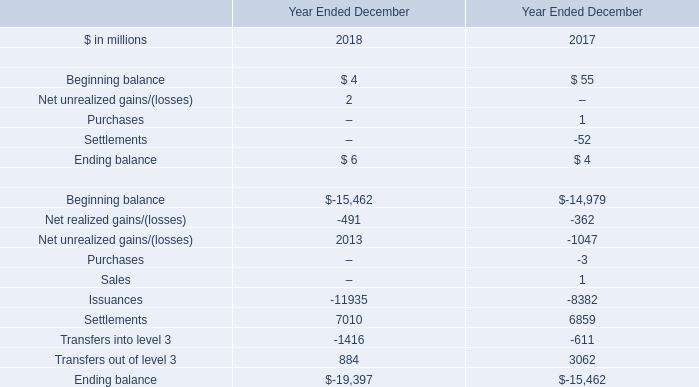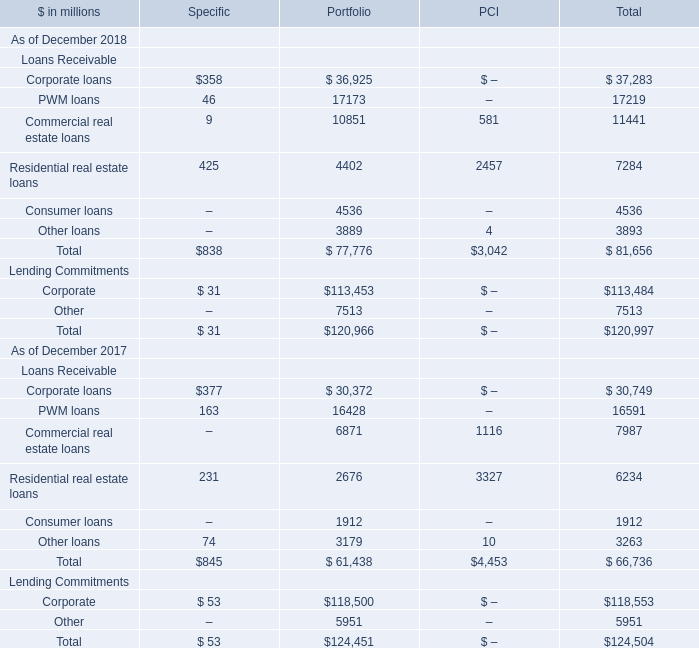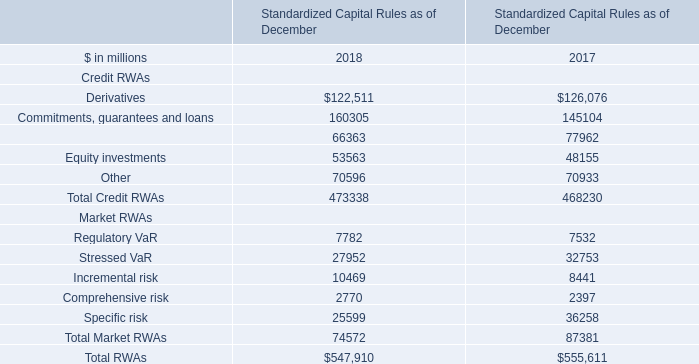what are the total market making revenues in the consolidated statements of earnings of 2017 , in billions? 
Computations: (9.45 / (1 + 23%))
Answer: 7.68293. 